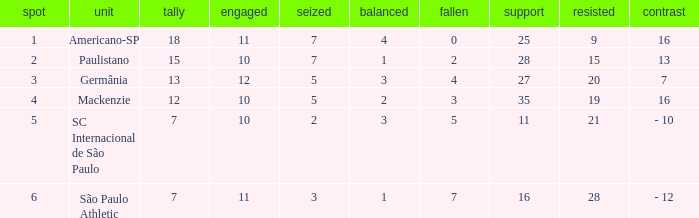Name the most for when difference is 7 27.0. 